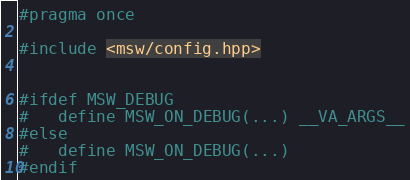<code> <loc_0><loc_0><loc_500><loc_500><_C++_>#pragma once

#include <msw/config.hpp>


#ifdef MSW_DEBUG
#   define MSW_ON_DEBUG(...) __VA_ARGS__
#else
#   define MSW_ON_DEBUG(...)
#endif
</code> 